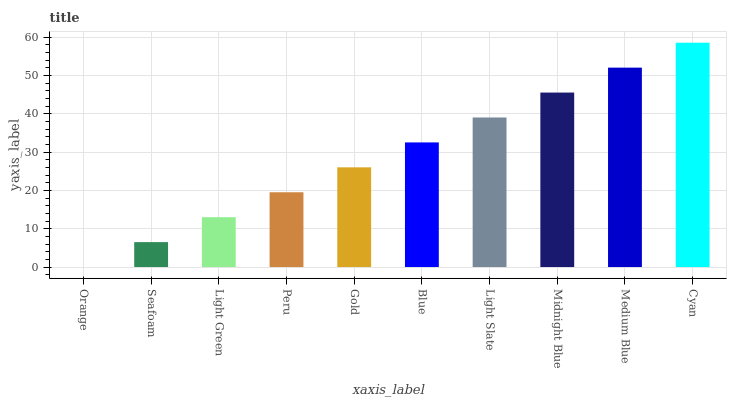Is Orange the minimum?
Answer yes or no. Yes. Is Cyan the maximum?
Answer yes or no. Yes. Is Seafoam the minimum?
Answer yes or no. No. Is Seafoam the maximum?
Answer yes or no. No. Is Seafoam greater than Orange?
Answer yes or no. Yes. Is Orange less than Seafoam?
Answer yes or no. Yes. Is Orange greater than Seafoam?
Answer yes or no. No. Is Seafoam less than Orange?
Answer yes or no. No. Is Blue the high median?
Answer yes or no. Yes. Is Gold the low median?
Answer yes or no. Yes. Is Midnight Blue the high median?
Answer yes or no. No. Is Cyan the low median?
Answer yes or no. No. 